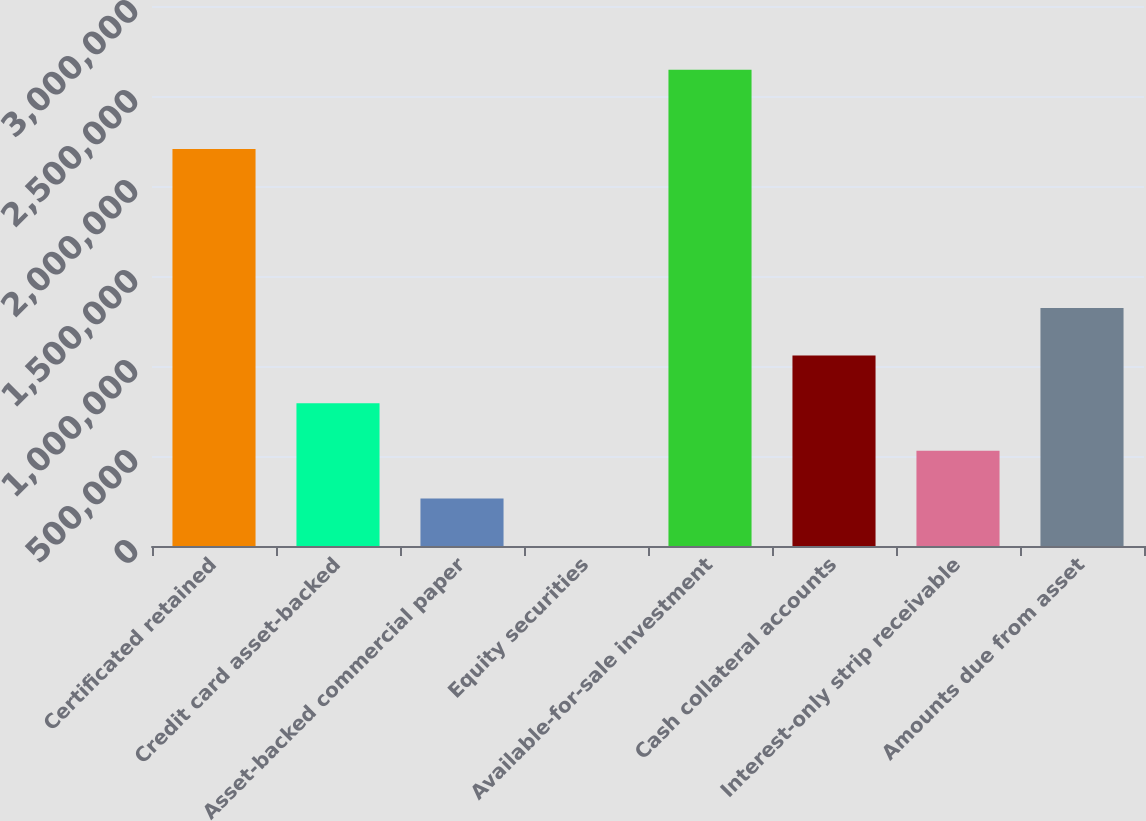<chart> <loc_0><loc_0><loc_500><loc_500><bar_chart><fcel>Certificated retained<fcel>Credit card asset-backed<fcel>Asset-backed commercial paper<fcel>Equity securities<fcel>Available-for-sale investment<fcel>Cash collateral accounts<fcel>Interest-only strip receivable<fcel>Amounts due from asset<nl><fcel>2.20497e+06<fcel>793641<fcel>264548<fcel>1.55<fcel>2.64547e+06<fcel>1.05819e+06<fcel>529094<fcel>1.32273e+06<nl></chart> 